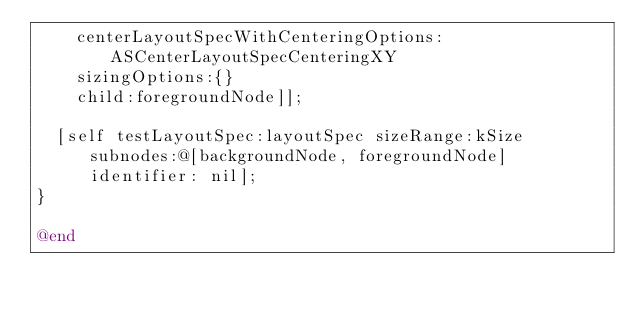<code> <loc_0><loc_0><loc_500><loc_500><_ObjectiveC_>    centerLayoutSpecWithCenteringOptions:ASCenterLayoutSpecCenteringXY
    sizingOptions:{}
    child:foregroundNode]];
  
  [self testLayoutSpec:layoutSpec sizeRange:kSize subnodes:@[backgroundNode, foregroundNode] identifier: nil];
}

@end
</code> 